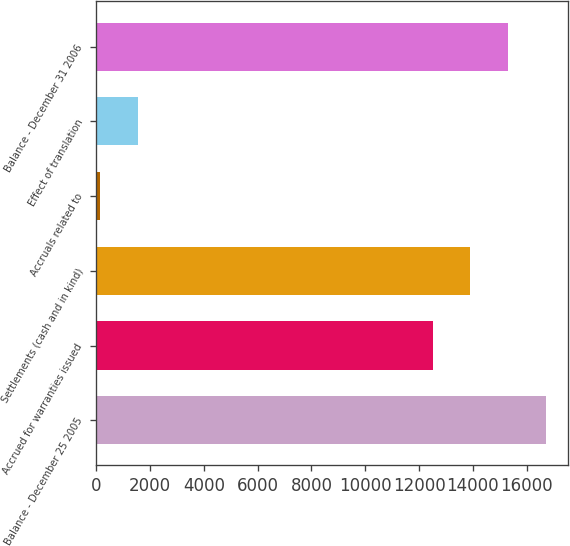<chart> <loc_0><loc_0><loc_500><loc_500><bar_chart><fcel>Balance - December 25 2005<fcel>Accrued for warranties issued<fcel>Settlements (cash and in kind)<fcel>Accruals related to<fcel>Effect of translation<fcel>Balance - December 31 2006<nl><fcel>16706.9<fcel>12503<fcel>13904.3<fcel>143<fcel>1544.3<fcel>15305.6<nl></chart> 